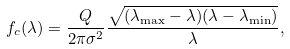Convert formula to latex. <formula><loc_0><loc_0><loc_500><loc_500>f _ { c } ( \lambda ) = \frac { Q } { 2 \pi \sigma ^ { 2 } } \frac { \sqrt { ( \lambda _ { \max } - \lambda ) ( \lambda - \lambda _ { \min } ) } } { \lambda } ,</formula> 